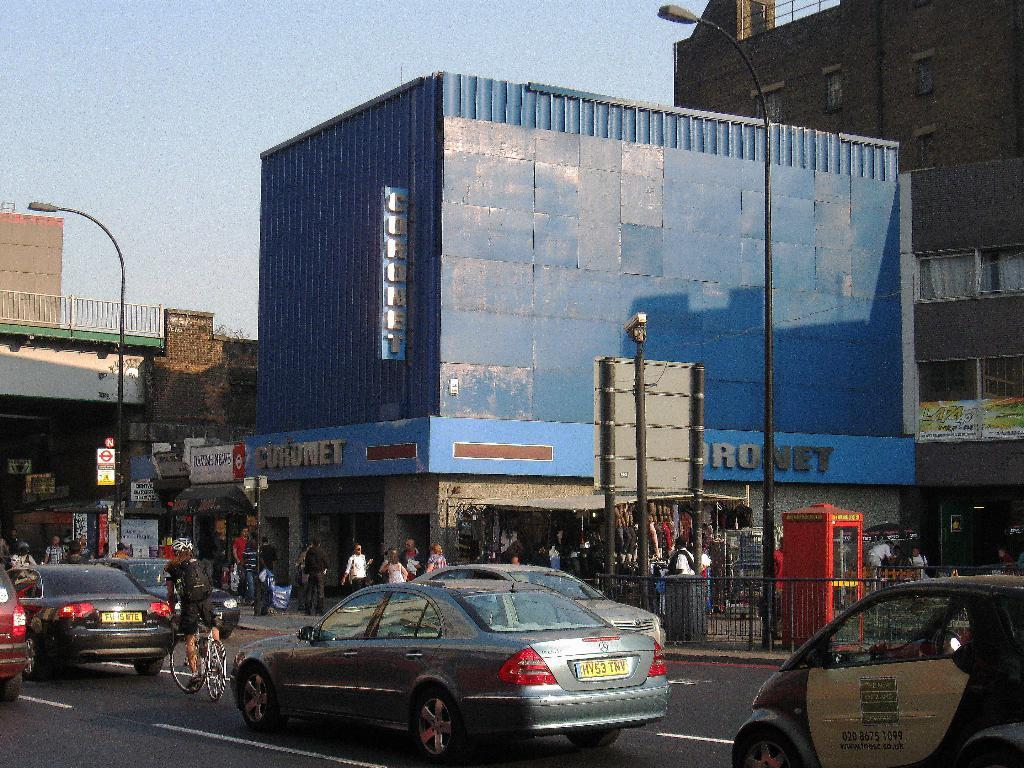What types of vehicles can be seen on the road in the image? There are cars and vehicles on the road in the image. What structures are visible in the image? There are buildings in the image. What else can be seen in the image besides cars and buildings? There are poles in the image. Can you describe any other unspecified elements in the image? There are other unspecified things in the image. What type of lettuce can be seen growing on the poles in the image? There is no lettuce present in the image; the poles are not associated with any plants or vegetation. 